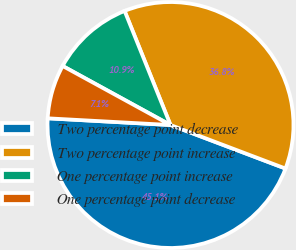<chart> <loc_0><loc_0><loc_500><loc_500><pie_chart><fcel>Two percentage point decrease<fcel>Two percentage point increase<fcel>One percentage point increase<fcel>One percentage point decrease<nl><fcel>45.11%<fcel>36.85%<fcel>10.94%<fcel>7.1%<nl></chart> 